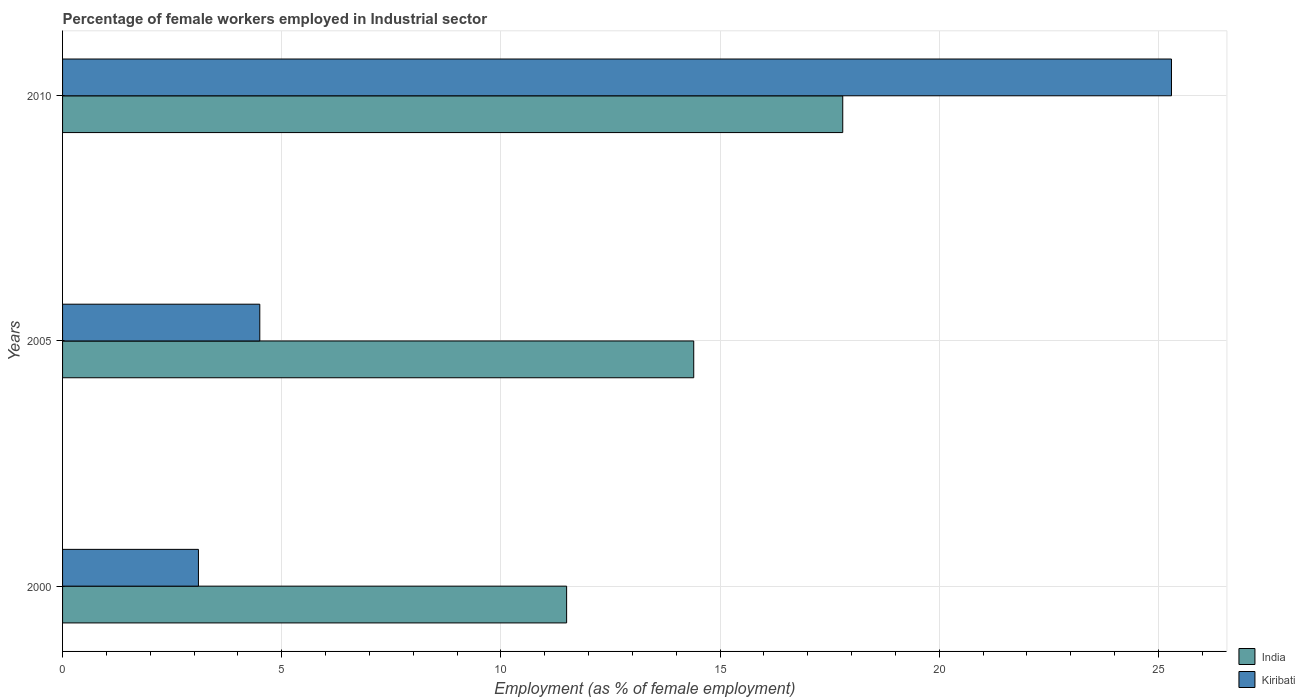Are the number of bars per tick equal to the number of legend labels?
Ensure brevity in your answer.  Yes. Are the number of bars on each tick of the Y-axis equal?
Keep it short and to the point. Yes. How many bars are there on the 1st tick from the bottom?
Keep it short and to the point. 2. What is the percentage of females employed in Industrial sector in Kiribati in 2005?
Provide a succinct answer. 4.5. Across all years, what is the maximum percentage of females employed in Industrial sector in Kiribati?
Your response must be concise. 25.3. Across all years, what is the minimum percentage of females employed in Industrial sector in Kiribati?
Ensure brevity in your answer.  3.1. In which year was the percentage of females employed in Industrial sector in Kiribati maximum?
Your response must be concise. 2010. In which year was the percentage of females employed in Industrial sector in India minimum?
Make the answer very short. 2000. What is the total percentage of females employed in Industrial sector in Kiribati in the graph?
Your answer should be compact. 32.9. What is the difference between the percentage of females employed in Industrial sector in India in 2000 and that in 2010?
Your answer should be compact. -6.3. What is the difference between the percentage of females employed in Industrial sector in Kiribati in 2005 and the percentage of females employed in Industrial sector in India in 2000?
Offer a terse response. -7. What is the average percentage of females employed in Industrial sector in Kiribati per year?
Ensure brevity in your answer.  10.97. In the year 2005, what is the difference between the percentage of females employed in Industrial sector in Kiribati and percentage of females employed in Industrial sector in India?
Offer a very short reply. -9.9. What is the ratio of the percentage of females employed in Industrial sector in Kiribati in 2000 to that in 2005?
Provide a short and direct response. 0.69. Is the percentage of females employed in Industrial sector in Kiribati in 2000 less than that in 2005?
Ensure brevity in your answer.  Yes. Is the difference between the percentage of females employed in Industrial sector in Kiribati in 2000 and 2005 greater than the difference between the percentage of females employed in Industrial sector in India in 2000 and 2005?
Provide a short and direct response. Yes. What is the difference between the highest and the second highest percentage of females employed in Industrial sector in India?
Give a very brief answer. 3.4. What is the difference between the highest and the lowest percentage of females employed in Industrial sector in Kiribati?
Your answer should be very brief. 22.2. Is the sum of the percentage of females employed in Industrial sector in India in 2005 and 2010 greater than the maximum percentage of females employed in Industrial sector in Kiribati across all years?
Your response must be concise. Yes. What does the 1st bar from the top in 2005 represents?
Your answer should be very brief. Kiribati. What does the 2nd bar from the bottom in 2010 represents?
Your answer should be compact. Kiribati. How many bars are there?
Give a very brief answer. 6. Are all the bars in the graph horizontal?
Offer a very short reply. Yes. Does the graph contain any zero values?
Provide a succinct answer. No. What is the title of the graph?
Provide a succinct answer. Percentage of female workers employed in Industrial sector. What is the label or title of the X-axis?
Provide a short and direct response. Employment (as % of female employment). What is the Employment (as % of female employment) in India in 2000?
Provide a short and direct response. 11.5. What is the Employment (as % of female employment) of Kiribati in 2000?
Provide a succinct answer. 3.1. What is the Employment (as % of female employment) in India in 2005?
Provide a succinct answer. 14.4. What is the Employment (as % of female employment) of India in 2010?
Offer a very short reply. 17.8. What is the Employment (as % of female employment) in Kiribati in 2010?
Keep it short and to the point. 25.3. Across all years, what is the maximum Employment (as % of female employment) of India?
Your answer should be compact. 17.8. Across all years, what is the maximum Employment (as % of female employment) in Kiribati?
Offer a very short reply. 25.3. Across all years, what is the minimum Employment (as % of female employment) in Kiribati?
Keep it short and to the point. 3.1. What is the total Employment (as % of female employment) in India in the graph?
Provide a succinct answer. 43.7. What is the total Employment (as % of female employment) in Kiribati in the graph?
Offer a terse response. 32.9. What is the difference between the Employment (as % of female employment) of India in 2000 and that in 2010?
Your response must be concise. -6.3. What is the difference between the Employment (as % of female employment) of Kiribati in 2000 and that in 2010?
Provide a short and direct response. -22.2. What is the difference between the Employment (as % of female employment) of India in 2005 and that in 2010?
Offer a terse response. -3.4. What is the difference between the Employment (as % of female employment) of Kiribati in 2005 and that in 2010?
Give a very brief answer. -20.8. What is the difference between the Employment (as % of female employment) in India in 2000 and the Employment (as % of female employment) in Kiribati in 2010?
Your answer should be very brief. -13.8. What is the average Employment (as % of female employment) in India per year?
Your answer should be very brief. 14.57. What is the average Employment (as % of female employment) of Kiribati per year?
Ensure brevity in your answer.  10.97. In the year 2000, what is the difference between the Employment (as % of female employment) in India and Employment (as % of female employment) in Kiribati?
Ensure brevity in your answer.  8.4. In the year 2010, what is the difference between the Employment (as % of female employment) in India and Employment (as % of female employment) in Kiribati?
Give a very brief answer. -7.5. What is the ratio of the Employment (as % of female employment) in India in 2000 to that in 2005?
Offer a very short reply. 0.8. What is the ratio of the Employment (as % of female employment) of Kiribati in 2000 to that in 2005?
Your response must be concise. 0.69. What is the ratio of the Employment (as % of female employment) of India in 2000 to that in 2010?
Provide a short and direct response. 0.65. What is the ratio of the Employment (as % of female employment) of Kiribati in 2000 to that in 2010?
Offer a terse response. 0.12. What is the ratio of the Employment (as % of female employment) of India in 2005 to that in 2010?
Provide a short and direct response. 0.81. What is the ratio of the Employment (as % of female employment) of Kiribati in 2005 to that in 2010?
Ensure brevity in your answer.  0.18. What is the difference between the highest and the second highest Employment (as % of female employment) in Kiribati?
Provide a succinct answer. 20.8. What is the difference between the highest and the lowest Employment (as % of female employment) of Kiribati?
Your answer should be very brief. 22.2. 